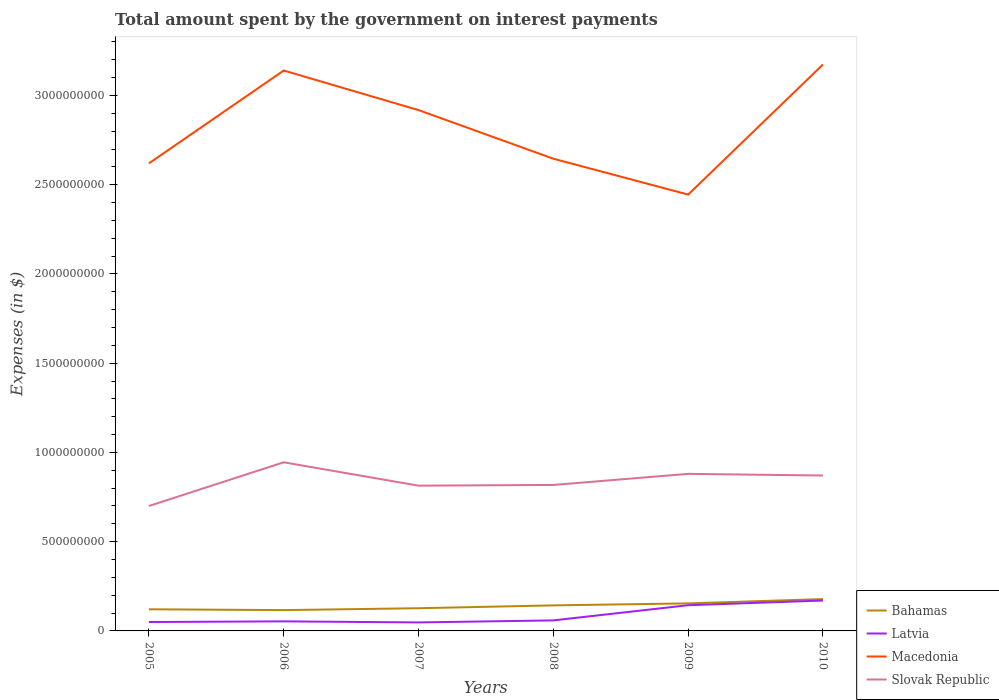How many different coloured lines are there?
Your answer should be compact. 4. Does the line corresponding to Slovak Republic intersect with the line corresponding to Latvia?
Make the answer very short. No. Across all years, what is the maximum amount spent on interest payments by the government in Latvia?
Provide a short and direct response. 4.76e+07. What is the total amount spent on interest payments by the government in Latvia in the graph?
Offer a very short reply. 5.99e+06. What is the difference between the highest and the second highest amount spent on interest payments by the government in Latvia?
Offer a very short reply. 1.23e+08. What is the difference between the highest and the lowest amount spent on interest payments by the government in Macedonia?
Your answer should be compact. 3. How many lines are there?
Ensure brevity in your answer.  4. What is the difference between two consecutive major ticks on the Y-axis?
Provide a succinct answer. 5.00e+08. Are the values on the major ticks of Y-axis written in scientific E-notation?
Provide a short and direct response. No. Does the graph contain grids?
Offer a terse response. No. What is the title of the graph?
Keep it short and to the point. Total amount spent by the government on interest payments. What is the label or title of the X-axis?
Provide a short and direct response. Years. What is the label or title of the Y-axis?
Ensure brevity in your answer.  Expenses (in $). What is the Expenses (in $) in Bahamas in 2005?
Provide a short and direct response. 1.21e+08. What is the Expenses (in $) of Latvia in 2005?
Offer a very short reply. 4.99e+07. What is the Expenses (in $) in Macedonia in 2005?
Provide a succinct answer. 2.62e+09. What is the Expenses (in $) in Slovak Republic in 2005?
Offer a terse response. 7.00e+08. What is the Expenses (in $) of Bahamas in 2006?
Provide a short and direct response. 1.17e+08. What is the Expenses (in $) of Latvia in 2006?
Give a very brief answer. 5.36e+07. What is the Expenses (in $) in Macedonia in 2006?
Keep it short and to the point. 3.14e+09. What is the Expenses (in $) in Slovak Republic in 2006?
Your answer should be very brief. 9.45e+08. What is the Expenses (in $) of Bahamas in 2007?
Provide a succinct answer. 1.27e+08. What is the Expenses (in $) in Latvia in 2007?
Provide a succinct answer. 4.76e+07. What is the Expenses (in $) in Macedonia in 2007?
Provide a short and direct response. 2.92e+09. What is the Expenses (in $) of Slovak Republic in 2007?
Your response must be concise. 8.14e+08. What is the Expenses (in $) in Bahamas in 2008?
Keep it short and to the point. 1.43e+08. What is the Expenses (in $) of Latvia in 2008?
Keep it short and to the point. 5.90e+07. What is the Expenses (in $) of Macedonia in 2008?
Give a very brief answer. 2.65e+09. What is the Expenses (in $) of Slovak Republic in 2008?
Offer a terse response. 8.18e+08. What is the Expenses (in $) in Bahamas in 2009?
Your answer should be very brief. 1.54e+08. What is the Expenses (in $) in Latvia in 2009?
Provide a succinct answer. 1.44e+08. What is the Expenses (in $) of Macedonia in 2009?
Provide a succinct answer. 2.44e+09. What is the Expenses (in $) in Slovak Republic in 2009?
Give a very brief answer. 8.80e+08. What is the Expenses (in $) of Bahamas in 2010?
Offer a very short reply. 1.78e+08. What is the Expenses (in $) in Latvia in 2010?
Make the answer very short. 1.70e+08. What is the Expenses (in $) of Macedonia in 2010?
Offer a terse response. 3.17e+09. What is the Expenses (in $) of Slovak Republic in 2010?
Give a very brief answer. 8.71e+08. Across all years, what is the maximum Expenses (in $) of Bahamas?
Provide a short and direct response. 1.78e+08. Across all years, what is the maximum Expenses (in $) in Latvia?
Make the answer very short. 1.70e+08. Across all years, what is the maximum Expenses (in $) of Macedonia?
Your answer should be compact. 3.17e+09. Across all years, what is the maximum Expenses (in $) in Slovak Republic?
Keep it short and to the point. 9.45e+08. Across all years, what is the minimum Expenses (in $) in Bahamas?
Your answer should be compact. 1.17e+08. Across all years, what is the minimum Expenses (in $) of Latvia?
Offer a terse response. 4.76e+07. Across all years, what is the minimum Expenses (in $) of Macedonia?
Give a very brief answer. 2.44e+09. Across all years, what is the minimum Expenses (in $) in Slovak Republic?
Offer a very short reply. 7.00e+08. What is the total Expenses (in $) of Bahamas in the graph?
Keep it short and to the point. 8.41e+08. What is the total Expenses (in $) of Latvia in the graph?
Make the answer very short. 5.24e+08. What is the total Expenses (in $) in Macedonia in the graph?
Keep it short and to the point. 1.69e+1. What is the total Expenses (in $) in Slovak Republic in the graph?
Your answer should be compact. 5.03e+09. What is the difference between the Expenses (in $) in Bahamas in 2005 and that in 2006?
Your response must be concise. 4.67e+06. What is the difference between the Expenses (in $) in Latvia in 2005 and that in 2006?
Keep it short and to the point. -3.70e+06. What is the difference between the Expenses (in $) in Macedonia in 2005 and that in 2006?
Provide a succinct answer. -5.20e+08. What is the difference between the Expenses (in $) in Slovak Republic in 2005 and that in 2006?
Make the answer very short. -2.45e+08. What is the difference between the Expenses (in $) of Bahamas in 2005 and that in 2007?
Your answer should be very brief. -5.92e+06. What is the difference between the Expenses (in $) of Latvia in 2005 and that in 2007?
Provide a short and direct response. 2.29e+06. What is the difference between the Expenses (in $) of Macedonia in 2005 and that in 2007?
Ensure brevity in your answer.  -2.99e+08. What is the difference between the Expenses (in $) of Slovak Republic in 2005 and that in 2007?
Offer a very short reply. -1.14e+08. What is the difference between the Expenses (in $) of Bahamas in 2005 and that in 2008?
Your response must be concise. -2.19e+07. What is the difference between the Expenses (in $) of Latvia in 2005 and that in 2008?
Provide a short and direct response. -9.10e+06. What is the difference between the Expenses (in $) of Macedonia in 2005 and that in 2008?
Give a very brief answer. -2.62e+07. What is the difference between the Expenses (in $) in Slovak Republic in 2005 and that in 2008?
Your answer should be compact. -1.18e+08. What is the difference between the Expenses (in $) in Bahamas in 2005 and that in 2009?
Provide a succinct answer. -3.30e+07. What is the difference between the Expenses (in $) in Latvia in 2005 and that in 2009?
Keep it short and to the point. -9.41e+07. What is the difference between the Expenses (in $) in Macedonia in 2005 and that in 2009?
Offer a terse response. 1.75e+08. What is the difference between the Expenses (in $) of Slovak Republic in 2005 and that in 2009?
Make the answer very short. -1.80e+08. What is the difference between the Expenses (in $) in Bahamas in 2005 and that in 2010?
Make the answer very short. -5.72e+07. What is the difference between the Expenses (in $) of Latvia in 2005 and that in 2010?
Your response must be concise. -1.20e+08. What is the difference between the Expenses (in $) of Macedonia in 2005 and that in 2010?
Ensure brevity in your answer.  -5.54e+08. What is the difference between the Expenses (in $) of Slovak Republic in 2005 and that in 2010?
Your response must be concise. -1.71e+08. What is the difference between the Expenses (in $) of Bahamas in 2006 and that in 2007?
Make the answer very short. -1.06e+07. What is the difference between the Expenses (in $) of Latvia in 2006 and that in 2007?
Ensure brevity in your answer.  5.99e+06. What is the difference between the Expenses (in $) in Macedonia in 2006 and that in 2007?
Offer a terse response. 2.22e+08. What is the difference between the Expenses (in $) of Slovak Republic in 2006 and that in 2007?
Your answer should be very brief. 1.31e+08. What is the difference between the Expenses (in $) of Bahamas in 2006 and that in 2008?
Give a very brief answer. -2.66e+07. What is the difference between the Expenses (in $) of Latvia in 2006 and that in 2008?
Make the answer very short. -5.40e+06. What is the difference between the Expenses (in $) of Macedonia in 2006 and that in 2008?
Provide a short and direct response. 4.94e+08. What is the difference between the Expenses (in $) in Slovak Republic in 2006 and that in 2008?
Your answer should be compact. 1.27e+08. What is the difference between the Expenses (in $) in Bahamas in 2006 and that in 2009?
Ensure brevity in your answer.  -3.76e+07. What is the difference between the Expenses (in $) of Latvia in 2006 and that in 2009?
Your response must be concise. -9.04e+07. What is the difference between the Expenses (in $) of Macedonia in 2006 and that in 2009?
Your answer should be very brief. 6.95e+08. What is the difference between the Expenses (in $) of Slovak Republic in 2006 and that in 2009?
Make the answer very short. 6.48e+07. What is the difference between the Expenses (in $) in Bahamas in 2006 and that in 2010?
Ensure brevity in your answer.  -6.19e+07. What is the difference between the Expenses (in $) of Latvia in 2006 and that in 2010?
Make the answer very short. -1.17e+08. What is the difference between the Expenses (in $) of Macedonia in 2006 and that in 2010?
Your answer should be very brief. -3.39e+07. What is the difference between the Expenses (in $) in Slovak Republic in 2006 and that in 2010?
Offer a terse response. 7.41e+07. What is the difference between the Expenses (in $) of Bahamas in 2007 and that in 2008?
Provide a succinct answer. -1.60e+07. What is the difference between the Expenses (in $) in Latvia in 2007 and that in 2008?
Your response must be concise. -1.14e+07. What is the difference between the Expenses (in $) in Macedonia in 2007 and that in 2008?
Give a very brief answer. 2.72e+08. What is the difference between the Expenses (in $) of Slovak Republic in 2007 and that in 2008?
Keep it short and to the point. -4.01e+06. What is the difference between the Expenses (in $) in Bahamas in 2007 and that in 2009?
Your response must be concise. -2.71e+07. What is the difference between the Expenses (in $) of Latvia in 2007 and that in 2009?
Offer a very short reply. -9.64e+07. What is the difference between the Expenses (in $) in Macedonia in 2007 and that in 2009?
Offer a very short reply. 4.73e+08. What is the difference between the Expenses (in $) in Slovak Republic in 2007 and that in 2009?
Offer a terse response. -6.61e+07. What is the difference between the Expenses (in $) of Bahamas in 2007 and that in 2010?
Give a very brief answer. -5.13e+07. What is the difference between the Expenses (in $) in Latvia in 2007 and that in 2010?
Provide a short and direct response. -1.23e+08. What is the difference between the Expenses (in $) of Macedonia in 2007 and that in 2010?
Offer a very short reply. -2.56e+08. What is the difference between the Expenses (in $) of Slovak Republic in 2007 and that in 2010?
Your answer should be very brief. -5.68e+07. What is the difference between the Expenses (in $) of Bahamas in 2008 and that in 2009?
Your response must be concise. -1.11e+07. What is the difference between the Expenses (in $) in Latvia in 2008 and that in 2009?
Your answer should be very brief. -8.50e+07. What is the difference between the Expenses (in $) in Macedonia in 2008 and that in 2009?
Provide a short and direct response. 2.01e+08. What is the difference between the Expenses (in $) in Slovak Republic in 2008 and that in 2009?
Offer a very short reply. -6.21e+07. What is the difference between the Expenses (in $) of Bahamas in 2008 and that in 2010?
Offer a very short reply. -3.53e+07. What is the difference between the Expenses (in $) in Latvia in 2008 and that in 2010?
Make the answer very short. -1.11e+08. What is the difference between the Expenses (in $) in Macedonia in 2008 and that in 2010?
Make the answer very short. -5.28e+08. What is the difference between the Expenses (in $) in Slovak Republic in 2008 and that in 2010?
Keep it short and to the point. -5.28e+07. What is the difference between the Expenses (in $) of Bahamas in 2009 and that in 2010?
Ensure brevity in your answer.  -2.42e+07. What is the difference between the Expenses (in $) in Latvia in 2009 and that in 2010?
Offer a terse response. -2.62e+07. What is the difference between the Expenses (in $) in Macedonia in 2009 and that in 2010?
Offer a terse response. -7.29e+08. What is the difference between the Expenses (in $) in Slovak Republic in 2009 and that in 2010?
Make the answer very short. 9.30e+06. What is the difference between the Expenses (in $) of Bahamas in 2005 and the Expenses (in $) of Latvia in 2006?
Provide a short and direct response. 6.76e+07. What is the difference between the Expenses (in $) in Bahamas in 2005 and the Expenses (in $) in Macedonia in 2006?
Provide a succinct answer. -3.02e+09. What is the difference between the Expenses (in $) of Bahamas in 2005 and the Expenses (in $) of Slovak Republic in 2006?
Your response must be concise. -8.24e+08. What is the difference between the Expenses (in $) of Latvia in 2005 and the Expenses (in $) of Macedonia in 2006?
Your response must be concise. -3.09e+09. What is the difference between the Expenses (in $) in Latvia in 2005 and the Expenses (in $) in Slovak Republic in 2006?
Provide a succinct answer. -8.95e+08. What is the difference between the Expenses (in $) of Macedonia in 2005 and the Expenses (in $) of Slovak Republic in 2006?
Your answer should be very brief. 1.67e+09. What is the difference between the Expenses (in $) in Bahamas in 2005 and the Expenses (in $) in Latvia in 2007?
Your answer should be compact. 7.36e+07. What is the difference between the Expenses (in $) in Bahamas in 2005 and the Expenses (in $) in Macedonia in 2007?
Provide a short and direct response. -2.80e+09. What is the difference between the Expenses (in $) of Bahamas in 2005 and the Expenses (in $) of Slovak Republic in 2007?
Your answer should be very brief. -6.93e+08. What is the difference between the Expenses (in $) in Latvia in 2005 and the Expenses (in $) in Macedonia in 2007?
Offer a terse response. -2.87e+09. What is the difference between the Expenses (in $) in Latvia in 2005 and the Expenses (in $) in Slovak Republic in 2007?
Give a very brief answer. -7.64e+08. What is the difference between the Expenses (in $) of Macedonia in 2005 and the Expenses (in $) of Slovak Republic in 2007?
Offer a very short reply. 1.81e+09. What is the difference between the Expenses (in $) in Bahamas in 2005 and the Expenses (in $) in Latvia in 2008?
Give a very brief answer. 6.22e+07. What is the difference between the Expenses (in $) of Bahamas in 2005 and the Expenses (in $) of Macedonia in 2008?
Provide a succinct answer. -2.52e+09. What is the difference between the Expenses (in $) of Bahamas in 2005 and the Expenses (in $) of Slovak Republic in 2008?
Your answer should be very brief. -6.97e+08. What is the difference between the Expenses (in $) in Latvia in 2005 and the Expenses (in $) in Macedonia in 2008?
Your response must be concise. -2.60e+09. What is the difference between the Expenses (in $) of Latvia in 2005 and the Expenses (in $) of Slovak Republic in 2008?
Ensure brevity in your answer.  -7.68e+08. What is the difference between the Expenses (in $) of Macedonia in 2005 and the Expenses (in $) of Slovak Republic in 2008?
Provide a short and direct response. 1.80e+09. What is the difference between the Expenses (in $) of Bahamas in 2005 and the Expenses (in $) of Latvia in 2009?
Make the answer very short. -2.28e+07. What is the difference between the Expenses (in $) in Bahamas in 2005 and the Expenses (in $) in Macedonia in 2009?
Your answer should be compact. -2.32e+09. What is the difference between the Expenses (in $) of Bahamas in 2005 and the Expenses (in $) of Slovak Republic in 2009?
Make the answer very short. -7.59e+08. What is the difference between the Expenses (in $) in Latvia in 2005 and the Expenses (in $) in Macedonia in 2009?
Offer a very short reply. -2.40e+09. What is the difference between the Expenses (in $) in Latvia in 2005 and the Expenses (in $) in Slovak Republic in 2009?
Provide a succinct answer. -8.30e+08. What is the difference between the Expenses (in $) in Macedonia in 2005 and the Expenses (in $) in Slovak Republic in 2009?
Provide a short and direct response. 1.74e+09. What is the difference between the Expenses (in $) in Bahamas in 2005 and the Expenses (in $) in Latvia in 2010?
Provide a succinct answer. -4.90e+07. What is the difference between the Expenses (in $) of Bahamas in 2005 and the Expenses (in $) of Macedonia in 2010?
Ensure brevity in your answer.  -3.05e+09. What is the difference between the Expenses (in $) of Bahamas in 2005 and the Expenses (in $) of Slovak Republic in 2010?
Your answer should be very brief. -7.50e+08. What is the difference between the Expenses (in $) in Latvia in 2005 and the Expenses (in $) in Macedonia in 2010?
Provide a short and direct response. -3.12e+09. What is the difference between the Expenses (in $) in Latvia in 2005 and the Expenses (in $) in Slovak Republic in 2010?
Make the answer very short. -8.21e+08. What is the difference between the Expenses (in $) in Macedonia in 2005 and the Expenses (in $) in Slovak Republic in 2010?
Your answer should be very brief. 1.75e+09. What is the difference between the Expenses (in $) of Bahamas in 2006 and the Expenses (in $) of Latvia in 2007?
Ensure brevity in your answer.  6.90e+07. What is the difference between the Expenses (in $) of Bahamas in 2006 and the Expenses (in $) of Macedonia in 2007?
Provide a short and direct response. -2.80e+09. What is the difference between the Expenses (in $) in Bahamas in 2006 and the Expenses (in $) in Slovak Republic in 2007?
Your answer should be compact. -6.97e+08. What is the difference between the Expenses (in $) of Latvia in 2006 and the Expenses (in $) of Macedonia in 2007?
Provide a short and direct response. -2.86e+09. What is the difference between the Expenses (in $) of Latvia in 2006 and the Expenses (in $) of Slovak Republic in 2007?
Your response must be concise. -7.60e+08. What is the difference between the Expenses (in $) of Macedonia in 2006 and the Expenses (in $) of Slovak Republic in 2007?
Your response must be concise. 2.33e+09. What is the difference between the Expenses (in $) in Bahamas in 2006 and the Expenses (in $) in Latvia in 2008?
Your answer should be compact. 5.76e+07. What is the difference between the Expenses (in $) in Bahamas in 2006 and the Expenses (in $) in Macedonia in 2008?
Offer a terse response. -2.53e+09. What is the difference between the Expenses (in $) in Bahamas in 2006 and the Expenses (in $) in Slovak Republic in 2008?
Keep it short and to the point. -7.01e+08. What is the difference between the Expenses (in $) in Latvia in 2006 and the Expenses (in $) in Macedonia in 2008?
Offer a terse response. -2.59e+09. What is the difference between the Expenses (in $) of Latvia in 2006 and the Expenses (in $) of Slovak Republic in 2008?
Offer a very short reply. -7.64e+08. What is the difference between the Expenses (in $) of Macedonia in 2006 and the Expenses (in $) of Slovak Republic in 2008?
Provide a succinct answer. 2.32e+09. What is the difference between the Expenses (in $) of Bahamas in 2006 and the Expenses (in $) of Latvia in 2009?
Your response must be concise. -2.75e+07. What is the difference between the Expenses (in $) of Bahamas in 2006 and the Expenses (in $) of Macedonia in 2009?
Offer a terse response. -2.33e+09. What is the difference between the Expenses (in $) in Bahamas in 2006 and the Expenses (in $) in Slovak Republic in 2009?
Make the answer very short. -7.63e+08. What is the difference between the Expenses (in $) in Latvia in 2006 and the Expenses (in $) in Macedonia in 2009?
Your response must be concise. -2.39e+09. What is the difference between the Expenses (in $) of Latvia in 2006 and the Expenses (in $) of Slovak Republic in 2009?
Provide a short and direct response. -8.26e+08. What is the difference between the Expenses (in $) of Macedonia in 2006 and the Expenses (in $) of Slovak Republic in 2009?
Keep it short and to the point. 2.26e+09. What is the difference between the Expenses (in $) in Bahamas in 2006 and the Expenses (in $) in Latvia in 2010?
Ensure brevity in your answer.  -5.37e+07. What is the difference between the Expenses (in $) of Bahamas in 2006 and the Expenses (in $) of Macedonia in 2010?
Your answer should be compact. -3.06e+09. What is the difference between the Expenses (in $) in Bahamas in 2006 and the Expenses (in $) in Slovak Republic in 2010?
Provide a short and direct response. -7.54e+08. What is the difference between the Expenses (in $) of Latvia in 2006 and the Expenses (in $) of Macedonia in 2010?
Your answer should be very brief. -3.12e+09. What is the difference between the Expenses (in $) in Latvia in 2006 and the Expenses (in $) in Slovak Republic in 2010?
Give a very brief answer. -8.17e+08. What is the difference between the Expenses (in $) in Macedonia in 2006 and the Expenses (in $) in Slovak Republic in 2010?
Offer a very short reply. 2.27e+09. What is the difference between the Expenses (in $) of Bahamas in 2007 and the Expenses (in $) of Latvia in 2008?
Your answer should be compact. 6.82e+07. What is the difference between the Expenses (in $) of Bahamas in 2007 and the Expenses (in $) of Macedonia in 2008?
Give a very brief answer. -2.52e+09. What is the difference between the Expenses (in $) of Bahamas in 2007 and the Expenses (in $) of Slovak Republic in 2008?
Keep it short and to the point. -6.91e+08. What is the difference between the Expenses (in $) in Latvia in 2007 and the Expenses (in $) in Macedonia in 2008?
Make the answer very short. -2.60e+09. What is the difference between the Expenses (in $) of Latvia in 2007 and the Expenses (in $) of Slovak Republic in 2008?
Provide a short and direct response. -7.70e+08. What is the difference between the Expenses (in $) in Macedonia in 2007 and the Expenses (in $) in Slovak Republic in 2008?
Your answer should be compact. 2.10e+09. What is the difference between the Expenses (in $) in Bahamas in 2007 and the Expenses (in $) in Latvia in 2009?
Give a very brief answer. -1.69e+07. What is the difference between the Expenses (in $) in Bahamas in 2007 and the Expenses (in $) in Macedonia in 2009?
Offer a terse response. -2.32e+09. What is the difference between the Expenses (in $) of Bahamas in 2007 and the Expenses (in $) of Slovak Republic in 2009?
Offer a very short reply. -7.53e+08. What is the difference between the Expenses (in $) of Latvia in 2007 and the Expenses (in $) of Macedonia in 2009?
Keep it short and to the point. -2.40e+09. What is the difference between the Expenses (in $) of Latvia in 2007 and the Expenses (in $) of Slovak Republic in 2009?
Give a very brief answer. -8.32e+08. What is the difference between the Expenses (in $) of Macedonia in 2007 and the Expenses (in $) of Slovak Republic in 2009?
Offer a terse response. 2.04e+09. What is the difference between the Expenses (in $) of Bahamas in 2007 and the Expenses (in $) of Latvia in 2010?
Offer a very short reply. -4.31e+07. What is the difference between the Expenses (in $) in Bahamas in 2007 and the Expenses (in $) in Macedonia in 2010?
Your response must be concise. -3.05e+09. What is the difference between the Expenses (in $) of Bahamas in 2007 and the Expenses (in $) of Slovak Republic in 2010?
Offer a terse response. -7.44e+08. What is the difference between the Expenses (in $) in Latvia in 2007 and the Expenses (in $) in Macedonia in 2010?
Give a very brief answer. -3.13e+09. What is the difference between the Expenses (in $) in Latvia in 2007 and the Expenses (in $) in Slovak Republic in 2010?
Make the answer very short. -8.23e+08. What is the difference between the Expenses (in $) of Macedonia in 2007 and the Expenses (in $) of Slovak Republic in 2010?
Your answer should be very brief. 2.05e+09. What is the difference between the Expenses (in $) in Bahamas in 2008 and the Expenses (in $) in Latvia in 2009?
Give a very brief answer. -9.12e+05. What is the difference between the Expenses (in $) of Bahamas in 2008 and the Expenses (in $) of Macedonia in 2009?
Make the answer very short. -2.30e+09. What is the difference between the Expenses (in $) of Bahamas in 2008 and the Expenses (in $) of Slovak Republic in 2009?
Give a very brief answer. -7.37e+08. What is the difference between the Expenses (in $) of Latvia in 2008 and the Expenses (in $) of Macedonia in 2009?
Ensure brevity in your answer.  -2.39e+09. What is the difference between the Expenses (in $) in Latvia in 2008 and the Expenses (in $) in Slovak Republic in 2009?
Make the answer very short. -8.21e+08. What is the difference between the Expenses (in $) in Macedonia in 2008 and the Expenses (in $) in Slovak Republic in 2009?
Provide a short and direct response. 1.77e+09. What is the difference between the Expenses (in $) of Bahamas in 2008 and the Expenses (in $) of Latvia in 2010?
Provide a succinct answer. -2.71e+07. What is the difference between the Expenses (in $) of Bahamas in 2008 and the Expenses (in $) of Macedonia in 2010?
Offer a terse response. -3.03e+09. What is the difference between the Expenses (in $) in Bahamas in 2008 and the Expenses (in $) in Slovak Republic in 2010?
Provide a succinct answer. -7.28e+08. What is the difference between the Expenses (in $) of Latvia in 2008 and the Expenses (in $) of Macedonia in 2010?
Your answer should be compact. -3.12e+09. What is the difference between the Expenses (in $) of Latvia in 2008 and the Expenses (in $) of Slovak Republic in 2010?
Ensure brevity in your answer.  -8.12e+08. What is the difference between the Expenses (in $) of Macedonia in 2008 and the Expenses (in $) of Slovak Republic in 2010?
Your response must be concise. 1.78e+09. What is the difference between the Expenses (in $) in Bahamas in 2009 and the Expenses (in $) in Latvia in 2010?
Ensure brevity in your answer.  -1.60e+07. What is the difference between the Expenses (in $) in Bahamas in 2009 and the Expenses (in $) in Macedonia in 2010?
Ensure brevity in your answer.  -3.02e+09. What is the difference between the Expenses (in $) of Bahamas in 2009 and the Expenses (in $) of Slovak Republic in 2010?
Your answer should be compact. -7.17e+08. What is the difference between the Expenses (in $) in Latvia in 2009 and the Expenses (in $) in Macedonia in 2010?
Offer a terse response. -3.03e+09. What is the difference between the Expenses (in $) of Latvia in 2009 and the Expenses (in $) of Slovak Republic in 2010?
Offer a very short reply. -7.27e+08. What is the difference between the Expenses (in $) in Macedonia in 2009 and the Expenses (in $) in Slovak Republic in 2010?
Provide a succinct answer. 1.57e+09. What is the average Expenses (in $) in Bahamas per year?
Your response must be concise. 1.40e+08. What is the average Expenses (in $) in Latvia per year?
Your answer should be very brief. 8.74e+07. What is the average Expenses (in $) in Macedonia per year?
Provide a succinct answer. 2.82e+09. What is the average Expenses (in $) in Slovak Republic per year?
Make the answer very short. 8.38e+08. In the year 2005, what is the difference between the Expenses (in $) in Bahamas and Expenses (in $) in Latvia?
Make the answer very short. 7.13e+07. In the year 2005, what is the difference between the Expenses (in $) of Bahamas and Expenses (in $) of Macedonia?
Ensure brevity in your answer.  -2.50e+09. In the year 2005, what is the difference between the Expenses (in $) in Bahamas and Expenses (in $) in Slovak Republic?
Offer a terse response. -5.79e+08. In the year 2005, what is the difference between the Expenses (in $) in Latvia and Expenses (in $) in Macedonia?
Provide a succinct answer. -2.57e+09. In the year 2005, what is the difference between the Expenses (in $) in Latvia and Expenses (in $) in Slovak Republic?
Keep it short and to the point. -6.50e+08. In the year 2005, what is the difference between the Expenses (in $) in Macedonia and Expenses (in $) in Slovak Republic?
Provide a short and direct response. 1.92e+09. In the year 2006, what is the difference between the Expenses (in $) of Bahamas and Expenses (in $) of Latvia?
Offer a terse response. 6.30e+07. In the year 2006, what is the difference between the Expenses (in $) in Bahamas and Expenses (in $) in Macedonia?
Give a very brief answer. -3.02e+09. In the year 2006, what is the difference between the Expenses (in $) of Bahamas and Expenses (in $) of Slovak Republic?
Your answer should be very brief. -8.28e+08. In the year 2006, what is the difference between the Expenses (in $) of Latvia and Expenses (in $) of Macedonia?
Your answer should be very brief. -3.09e+09. In the year 2006, what is the difference between the Expenses (in $) in Latvia and Expenses (in $) in Slovak Republic?
Your answer should be very brief. -8.91e+08. In the year 2006, what is the difference between the Expenses (in $) of Macedonia and Expenses (in $) of Slovak Republic?
Offer a very short reply. 2.20e+09. In the year 2007, what is the difference between the Expenses (in $) in Bahamas and Expenses (in $) in Latvia?
Provide a succinct answer. 7.96e+07. In the year 2007, what is the difference between the Expenses (in $) of Bahamas and Expenses (in $) of Macedonia?
Offer a very short reply. -2.79e+09. In the year 2007, what is the difference between the Expenses (in $) in Bahamas and Expenses (in $) in Slovak Republic?
Keep it short and to the point. -6.87e+08. In the year 2007, what is the difference between the Expenses (in $) of Latvia and Expenses (in $) of Macedonia?
Your answer should be very brief. -2.87e+09. In the year 2007, what is the difference between the Expenses (in $) of Latvia and Expenses (in $) of Slovak Republic?
Your answer should be very brief. -7.66e+08. In the year 2007, what is the difference between the Expenses (in $) in Macedonia and Expenses (in $) in Slovak Republic?
Ensure brevity in your answer.  2.10e+09. In the year 2008, what is the difference between the Expenses (in $) in Bahamas and Expenses (in $) in Latvia?
Make the answer very short. 8.41e+07. In the year 2008, what is the difference between the Expenses (in $) of Bahamas and Expenses (in $) of Macedonia?
Your answer should be very brief. -2.50e+09. In the year 2008, what is the difference between the Expenses (in $) in Bahamas and Expenses (in $) in Slovak Republic?
Provide a succinct answer. -6.75e+08. In the year 2008, what is the difference between the Expenses (in $) of Latvia and Expenses (in $) of Macedonia?
Ensure brevity in your answer.  -2.59e+09. In the year 2008, what is the difference between the Expenses (in $) in Latvia and Expenses (in $) in Slovak Republic?
Offer a terse response. -7.59e+08. In the year 2008, what is the difference between the Expenses (in $) of Macedonia and Expenses (in $) of Slovak Republic?
Keep it short and to the point. 1.83e+09. In the year 2009, what is the difference between the Expenses (in $) in Bahamas and Expenses (in $) in Latvia?
Your response must be concise. 1.02e+07. In the year 2009, what is the difference between the Expenses (in $) of Bahamas and Expenses (in $) of Macedonia?
Give a very brief answer. -2.29e+09. In the year 2009, what is the difference between the Expenses (in $) in Bahamas and Expenses (in $) in Slovak Republic?
Your answer should be compact. -7.26e+08. In the year 2009, what is the difference between the Expenses (in $) in Latvia and Expenses (in $) in Macedonia?
Make the answer very short. -2.30e+09. In the year 2009, what is the difference between the Expenses (in $) in Latvia and Expenses (in $) in Slovak Republic?
Keep it short and to the point. -7.36e+08. In the year 2009, what is the difference between the Expenses (in $) of Macedonia and Expenses (in $) of Slovak Republic?
Your answer should be very brief. 1.56e+09. In the year 2010, what is the difference between the Expenses (in $) in Bahamas and Expenses (in $) in Latvia?
Offer a very short reply. 8.21e+06. In the year 2010, what is the difference between the Expenses (in $) of Bahamas and Expenses (in $) of Macedonia?
Provide a succinct answer. -3.00e+09. In the year 2010, what is the difference between the Expenses (in $) in Bahamas and Expenses (in $) in Slovak Republic?
Ensure brevity in your answer.  -6.92e+08. In the year 2010, what is the difference between the Expenses (in $) of Latvia and Expenses (in $) of Macedonia?
Your answer should be compact. -3.00e+09. In the year 2010, what is the difference between the Expenses (in $) in Latvia and Expenses (in $) in Slovak Republic?
Your response must be concise. -7.01e+08. In the year 2010, what is the difference between the Expenses (in $) in Macedonia and Expenses (in $) in Slovak Republic?
Provide a succinct answer. 2.30e+09. What is the ratio of the Expenses (in $) of Bahamas in 2005 to that in 2006?
Keep it short and to the point. 1.04. What is the ratio of the Expenses (in $) of Latvia in 2005 to that in 2006?
Offer a very short reply. 0.93. What is the ratio of the Expenses (in $) in Macedonia in 2005 to that in 2006?
Give a very brief answer. 0.83. What is the ratio of the Expenses (in $) in Slovak Republic in 2005 to that in 2006?
Your answer should be compact. 0.74. What is the ratio of the Expenses (in $) in Bahamas in 2005 to that in 2007?
Give a very brief answer. 0.95. What is the ratio of the Expenses (in $) in Latvia in 2005 to that in 2007?
Ensure brevity in your answer.  1.05. What is the ratio of the Expenses (in $) of Macedonia in 2005 to that in 2007?
Offer a terse response. 0.9. What is the ratio of the Expenses (in $) in Slovak Republic in 2005 to that in 2007?
Provide a succinct answer. 0.86. What is the ratio of the Expenses (in $) in Bahamas in 2005 to that in 2008?
Your answer should be very brief. 0.85. What is the ratio of the Expenses (in $) of Latvia in 2005 to that in 2008?
Make the answer very short. 0.85. What is the ratio of the Expenses (in $) in Slovak Republic in 2005 to that in 2008?
Your answer should be compact. 0.86. What is the ratio of the Expenses (in $) of Bahamas in 2005 to that in 2009?
Provide a short and direct response. 0.79. What is the ratio of the Expenses (in $) of Latvia in 2005 to that in 2009?
Make the answer very short. 0.35. What is the ratio of the Expenses (in $) of Macedonia in 2005 to that in 2009?
Offer a very short reply. 1.07. What is the ratio of the Expenses (in $) in Slovak Republic in 2005 to that in 2009?
Give a very brief answer. 0.8. What is the ratio of the Expenses (in $) of Bahamas in 2005 to that in 2010?
Provide a succinct answer. 0.68. What is the ratio of the Expenses (in $) of Latvia in 2005 to that in 2010?
Ensure brevity in your answer.  0.29. What is the ratio of the Expenses (in $) in Macedonia in 2005 to that in 2010?
Offer a very short reply. 0.83. What is the ratio of the Expenses (in $) in Slovak Republic in 2005 to that in 2010?
Keep it short and to the point. 0.8. What is the ratio of the Expenses (in $) of Bahamas in 2006 to that in 2007?
Your response must be concise. 0.92. What is the ratio of the Expenses (in $) of Latvia in 2006 to that in 2007?
Your response must be concise. 1.13. What is the ratio of the Expenses (in $) in Macedonia in 2006 to that in 2007?
Your answer should be very brief. 1.08. What is the ratio of the Expenses (in $) in Slovak Republic in 2006 to that in 2007?
Provide a succinct answer. 1.16. What is the ratio of the Expenses (in $) of Bahamas in 2006 to that in 2008?
Give a very brief answer. 0.81. What is the ratio of the Expenses (in $) in Latvia in 2006 to that in 2008?
Your response must be concise. 0.91. What is the ratio of the Expenses (in $) in Macedonia in 2006 to that in 2008?
Keep it short and to the point. 1.19. What is the ratio of the Expenses (in $) of Slovak Republic in 2006 to that in 2008?
Make the answer very short. 1.16. What is the ratio of the Expenses (in $) of Bahamas in 2006 to that in 2009?
Offer a terse response. 0.76. What is the ratio of the Expenses (in $) of Latvia in 2006 to that in 2009?
Make the answer very short. 0.37. What is the ratio of the Expenses (in $) in Macedonia in 2006 to that in 2009?
Keep it short and to the point. 1.28. What is the ratio of the Expenses (in $) of Slovak Republic in 2006 to that in 2009?
Offer a terse response. 1.07. What is the ratio of the Expenses (in $) in Bahamas in 2006 to that in 2010?
Make the answer very short. 0.65. What is the ratio of the Expenses (in $) of Latvia in 2006 to that in 2010?
Offer a very short reply. 0.31. What is the ratio of the Expenses (in $) of Macedonia in 2006 to that in 2010?
Your answer should be very brief. 0.99. What is the ratio of the Expenses (in $) in Slovak Republic in 2006 to that in 2010?
Offer a very short reply. 1.09. What is the ratio of the Expenses (in $) in Bahamas in 2007 to that in 2008?
Your answer should be very brief. 0.89. What is the ratio of the Expenses (in $) of Latvia in 2007 to that in 2008?
Give a very brief answer. 0.81. What is the ratio of the Expenses (in $) in Macedonia in 2007 to that in 2008?
Your answer should be very brief. 1.1. What is the ratio of the Expenses (in $) of Bahamas in 2007 to that in 2009?
Offer a terse response. 0.82. What is the ratio of the Expenses (in $) of Latvia in 2007 to that in 2009?
Offer a terse response. 0.33. What is the ratio of the Expenses (in $) of Macedonia in 2007 to that in 2009?
Give a very brief answer. 1.19. What is the ratio of the Expenses (in $) in Slovak Republic in 2007 to that in 2009?
Offer a terse response. 0.92. What is the ratio of the Expenses (in $) of Bahamas in 2007 to that in 2010?
Make the answer very short. 0.71. What is the ratio of the Expenses (in $) of Latvia in 2007 to that in 2010?
Your response must be concise. 0.28. What is the ratio of the Expenses (in $) of Macedonia in 2007 to that in 2010?
Give a very brief answer. 0.92. What is the ratio of the Expenses (in $) in Slovak Republic in 2007 to that in 2010?
Your response must be concise. 0.93. What is the ratio of the Expenses (in $) of Bahamas in 2008 to that in 2009?
Keep it short and to the point. 0.93. What is the ratio of the Expenses (in $) in Latvia in 2008 to that in 2009?
Offer a terse response. 0.41. What is the ratio of the Expenses (in $) of Macedonia in 2008 to that in 2009?
Your answer should be compact. 1.08. What is the ratio of the Expenses (in $) of Slovak Republic in 2008 to that in 2009?
Ensure brevity in your answer.  0.93. What is the ratio of the Expenses (in $) of Bahamas in 2008 to that in 2010?
Your answer should be very brief. 0.8. What is the ratio of the Expenses (in $) of Latvia in 2008 to that in 2010?
Provide a short and direct response. 0.35. What is the ratio of the Expenses (in $) of Macedonia in 2008 to that in 2010?
Give a very brief answer. 0.83. What is the ratio of the Expenses (in $) in Slovak Republic in 2008 to that in 2010?
Your answer should be very brief. 0.94. What is the ratio of the Expenses (in $) of Bahamas in 2009 to that in 2010?
Your answer should be very brief. 0.86. What is the ratio of the Expenses (in $) in Latvia in 2009 to that in 2010?
Ensure brevity in your answer.  0.85. What is the ratio of the Expenses (in $) in Macedonia in 2009 to that in 2010?
Keep it short and to the point. 0.77. What is the ratio of the Expenses (in $) in Slovak Republic in 2009 to that in 2010?
Your answer should be very brief. 1.01. What is the difference between the highest and the second highest Expenses (in $) in Bahamas?
Your response must be concise. 2.42e+07. What is the difference between the highest and the second highest Expenses (in $) of Latvia?
Offer a terse response. 2.62e+07. What is the difference between the highest and the second highest Expenses (in $) in Macedonia?
Offer a very short reply. 3.39e+07. What is the difference between the highest and the second highest Expenses (in $) in Slovak Republic?
Offer a terse response. 6.48e+07. What is the difference between the highest and the lowest Expenses (in $) in Bahamas?
Your answer should be compact. 6.19e+07. What is the difference between the highest and the lowest Expenses (in $) in Latvia?
Make the answer very short. 1.23e+08. What is the difference between the highest and the lowest Expenses (in $) in Macedonia?
Give a very brief answer. 7.29e+08. What is the difference between the highest and the lowest Expenses (in $) of Slovak Republic?
Keep it short and to the point. 2.45e+08. 